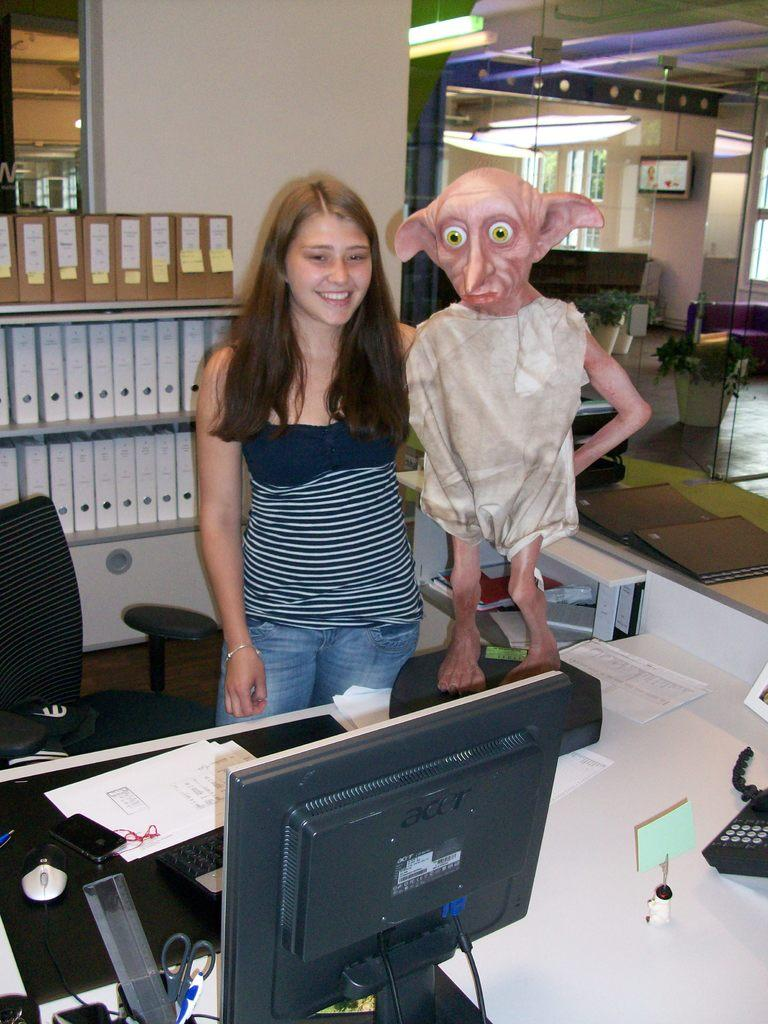What is the main subject of the image? There is a girl standing in the image. What can be seen in the background of the image? There is a table in the image. What is on the table? There is a monitor, a telephone, and papers on the table. Can you see a pig walking on the sidewalk in the image? No, there is no pig or sidewalk present in the image. 